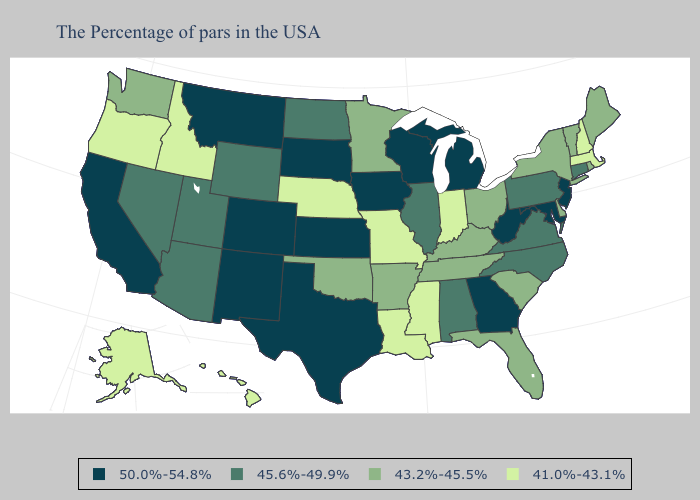What is the lowest value in states that border South Carolina?
Give a very brief answer. 45.6%-49.9%. Which states hav the highest value in the Northeast?
Quick response, please. New Jersey. What is the highest value in the MidWest ?
Be succinct. 50.0%-54.8%. What is the lowest value in the Northeast?
Concise answer only. 41.0%-43.1%. Does the first symbol in the legend represent the smallest category?
Concise answer only. No. Does Alabama have the same value as Virginia?
Give a very brief answer. Yes. What is the highest value in the USA?
Write a very short answer. 50.0%-54.8%. What is the lowest value in the USA?
Short answer required. 41.0%-43.1%. What is the value of Colorado?
Keep it brief. 50.0%-54.8%. What is the lowest value in the USA?
Quick response, please. 41.0%-43.1%. What is the highest value in states that border South Carolina?
Answer briefly. 50.0%-54.8%. Name the states that have a value in the range 41.0%-43.1%?
Write a very short answer. Massachusetts, New Hampshire, Indiana, Mississippi, Louisiana, Missouri, Nebraska, Idaho, Oregon, Alaska, Hawaii. What is the value of Alabama?
Write a very short answer. 45.6%-49.9%. Among the states that border Connecticut , does Massachusetts have the lowest value?
Write a very short answer. Yes. Which states hav the highest value in the Northeast?
Give a very brief answer. New Jersey. 